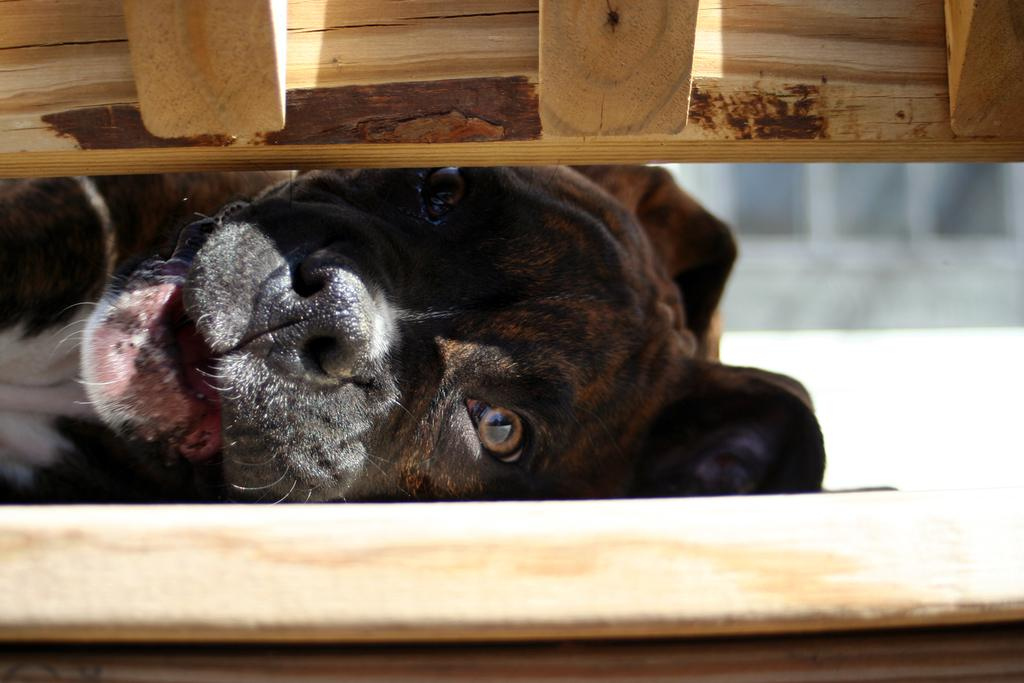What animal can be seen in the image? There is a dog in the image. Can you describe the dog's surroundings? The dog is between a wooden fence. How many apples are on the ground near the dog in the image? There are no apples present in the image. 